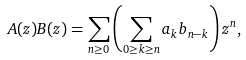<formula> <loc_0><loc_0><loc_500><loc_500>A ( z ) B ( z ) = \sum _ { n \geq 0 } \left ( \sum _ { 0 \geq k \geq n } a _ { k } b _ { n - k } \right ) z ^ { n } ,</formula> 